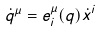Convert formula to latex. <formula><loc_0><loc_0><loc_500><loc_500>\dot { q } ^ { \mu } = e _ { i } ^ { \mu } ( q ) \dot { x } ^ { i }</formula> 